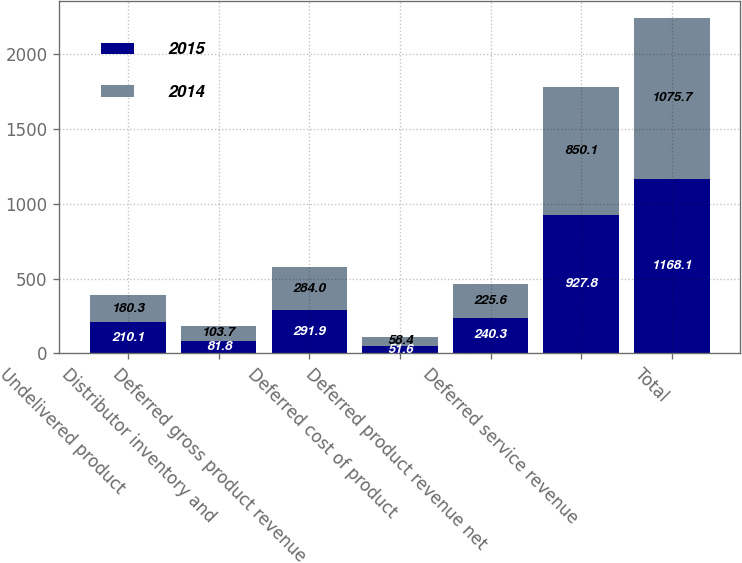Convert chart. <chart><loc_0><loc_0><loc_500><loc_500><stacked_bar_chart><ecel><fcel>Undelivered product<fcel>Distributor inventory and<fcel>Deferred gross product revenue<fcel>Deferred cost of product<fcel>Deferred product revenue net<fcel>Deferred service revenue<fcel>Total<nl><fcel>2015<fcel>210.1<fcel>81.8<fcel>291.9<fcel>51.6<fcel>240.3<fcel>927.8<fcel>1168.1<nl><fcel>2014<fcel>180.3<fcel>103.7<fcel>284<fcel>58.4<fcel>225.6<fcel>850.1<fcel>1075.7<nl></chart> 